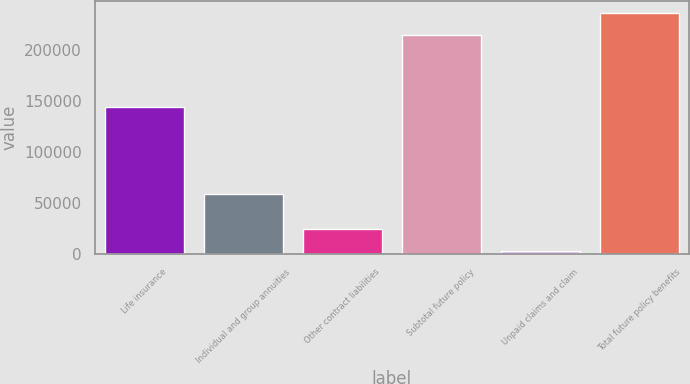Convert chart. <chart><loc_0><loc_0><loc_500><loc_500><bar_chart><fcel>Life insurance<fcel>Individual and group annuities<fcel>Other contract liabilities<fcel>Subtotal future policy<fcel>Unpaid claims and claim<fcel>Total future policy benefits<nl><fcel>143842<fcel>58699<fcel>24524.3<fcel>214713<fcel>3053<fcel>236184<nl></chart> 